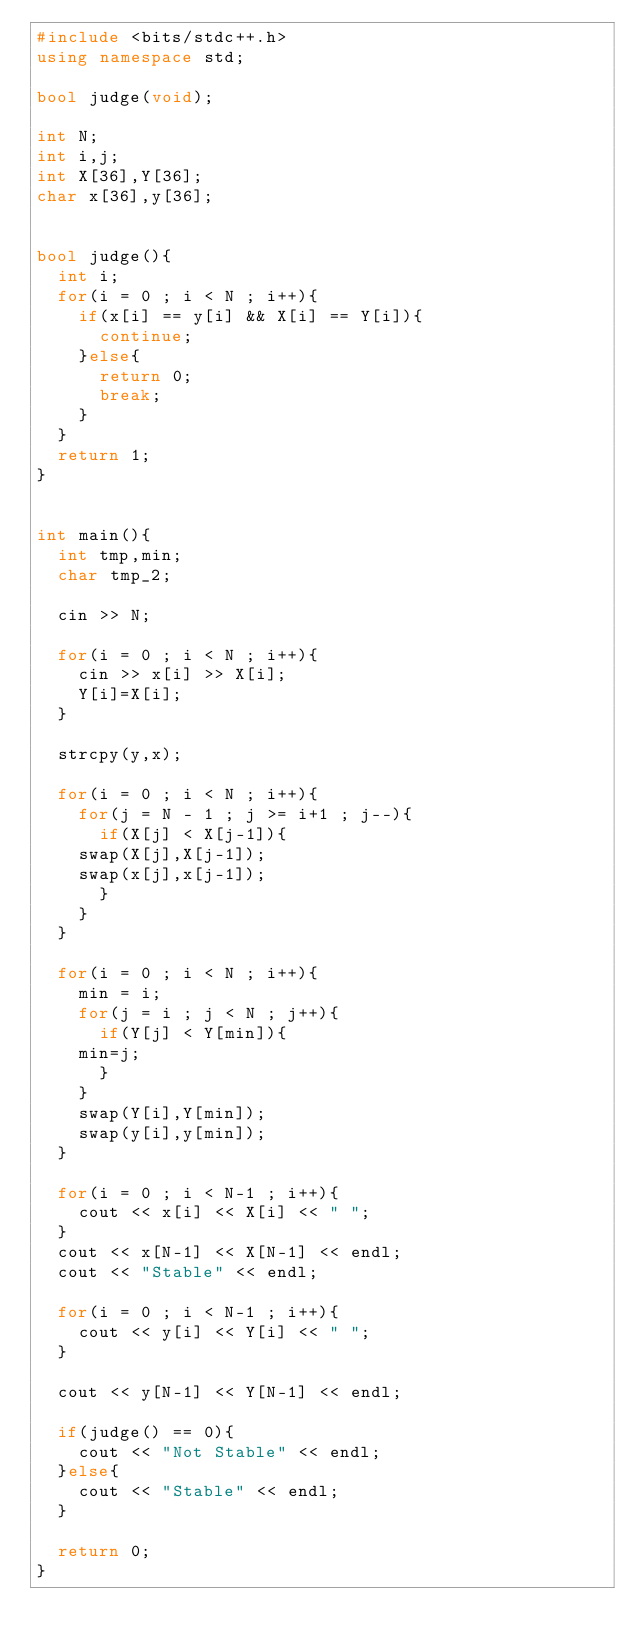<code> <loc_0><loc_0><loc_500><loc_500><_C++_>#include <bits/stdc++.h>
using namespace std;

bool judge(void);

int N;
int i,j;
int X[36],Y[36];
char x[36],y[36];


bool judge(){
  int i;
  for(i = 0 ; i < N ; i++){
    if(x[i] == y[i] && X[i] == Y[i]){
      continue;
    }else{
      return 0;
      break;
    }
  }
  return 1;
}
    

int main(){
  int tmp,min;
  char tmp_2;

  cin >> N;

  for(i = 0 ; i < N ; i++){
    cin >> x[i] >> X[i];
    Y[i]=X[i];
  }

  strcpy(y,x);

  for(i = 0 ; i < N ; i++){
    for(j = N - 1 ; j >= i+1 ; j--){
      if(X[j] < X[j-1]){
	swap(X[j],X[j-1]);
	swap(x[j],x[j-1]);
      }
    }
  }

  for(i = 0 ; i < N ; i++){
    min = i;
    for(j = i ; j < N ; j++){
      if(Y[j] < Y[min]){
	min=j;
      }
    }
    swap(Y[i],Y[min]);    
    swap(y[i],y[min]);
  }

  for(i = 0 ; i < N-1 ; i++){
    cout << x[i] << X[i] << " ";
  }
  cout << x[N-1] << X[N-1] << endl;
  cout << "Stable" << endl;

  for(i = 0 ; i < N-1 ; i++){
    cout << y[i] << Y[i] << " ";
  }
 
  cout << y[N-1] << Y[N-1] << endl;

  if(judge() == 0){
    cout << "Not Stable" << endl;
  }else{
    cout << "Stable" << endl;
  }

  return 0;
}</code> 